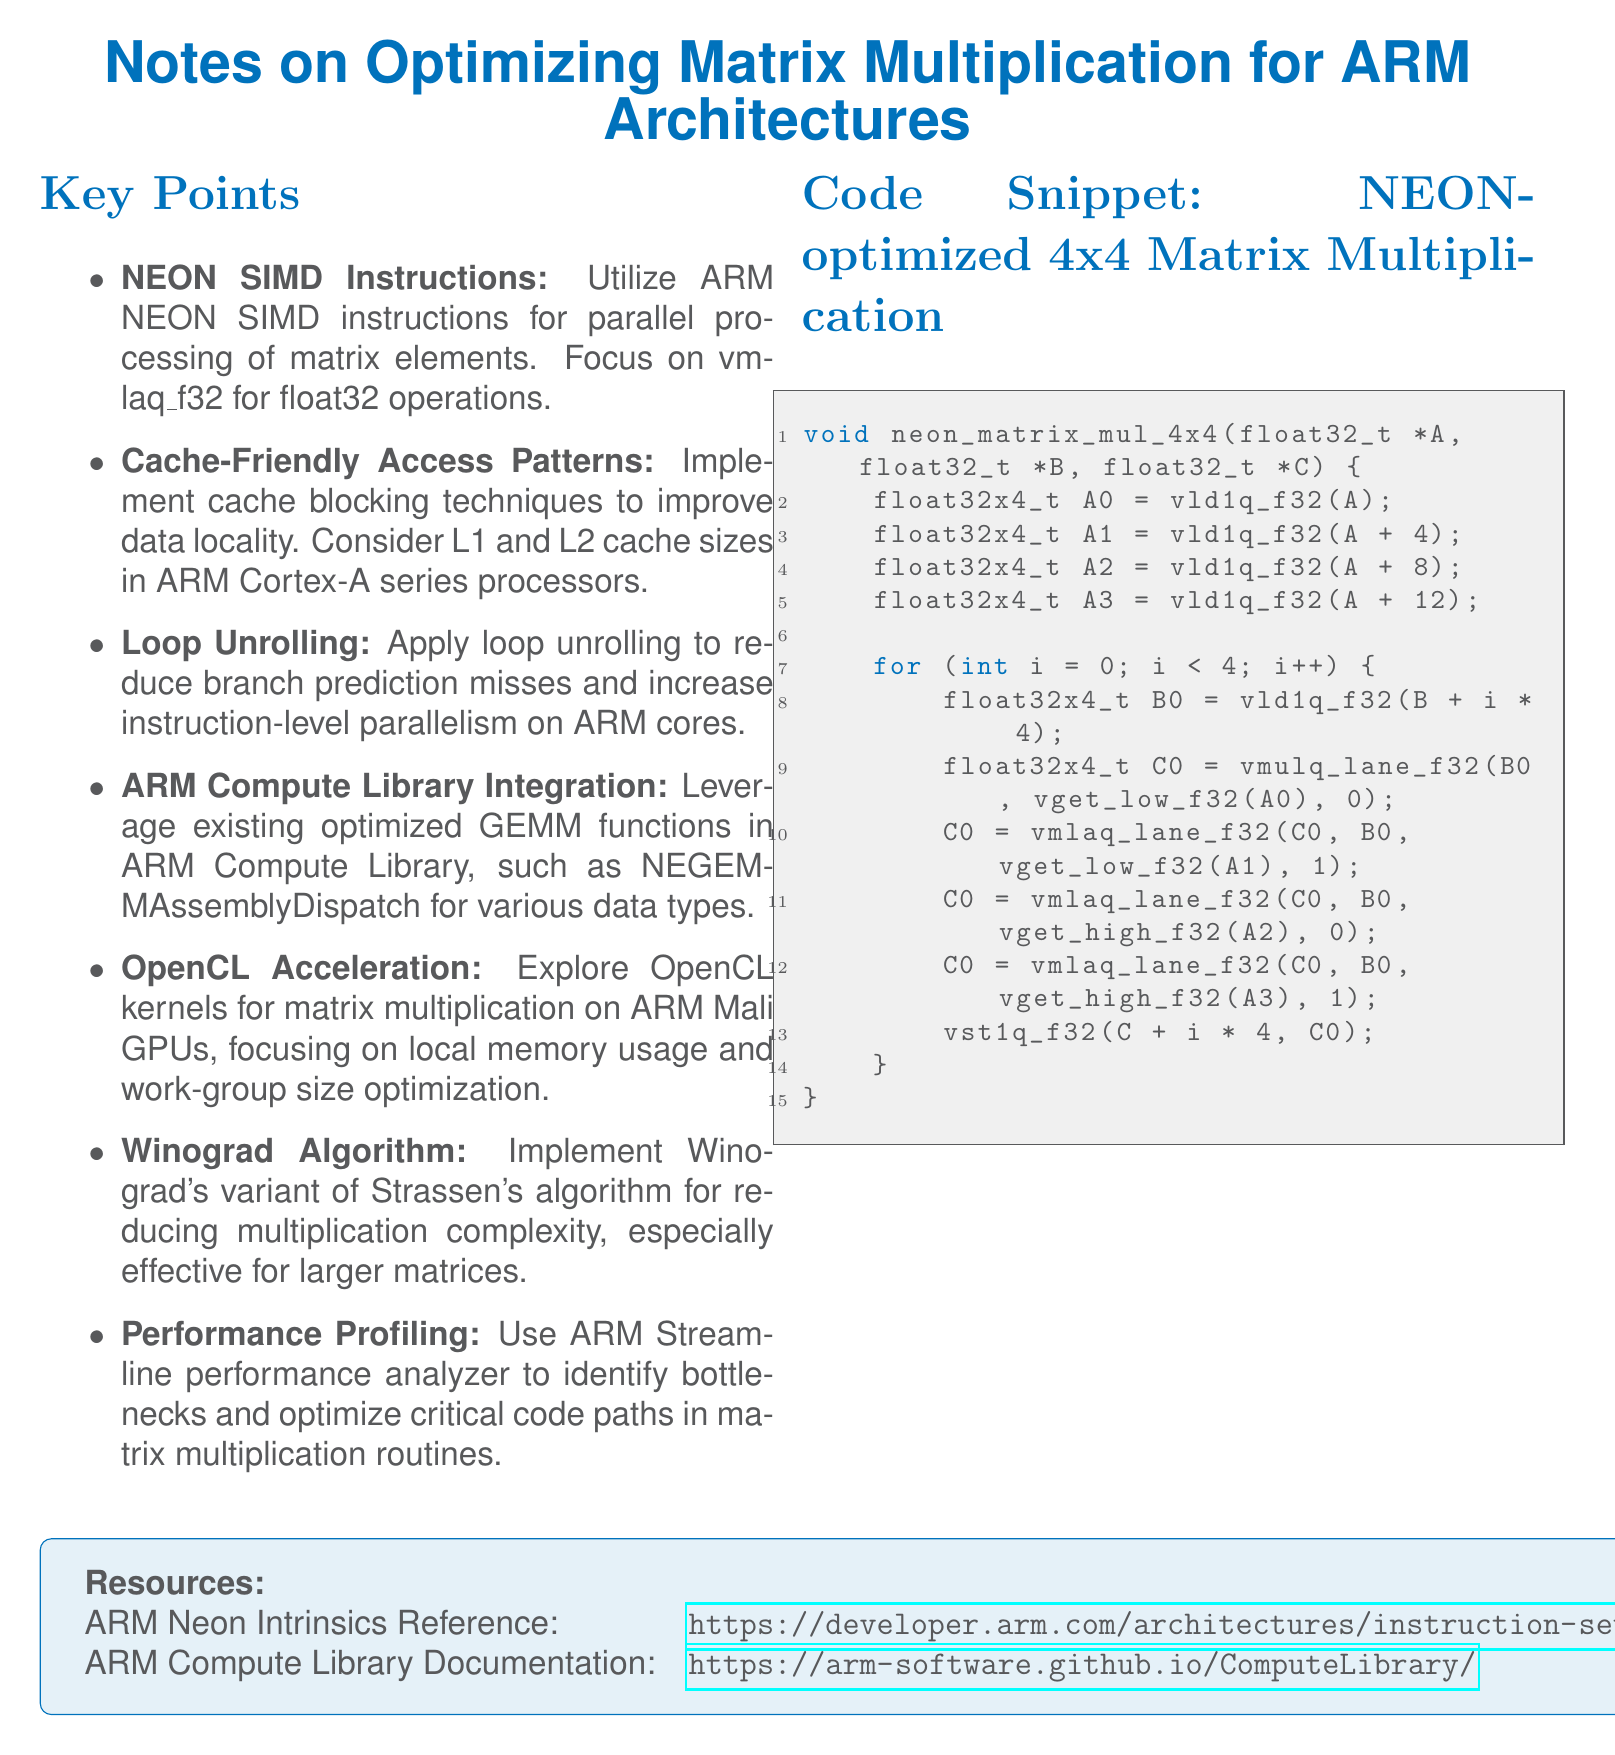What is the focus of NEON SIMD instructions? The NEON SIMD instructions focus on parallel processing of matrix elements, specifically vmlaq_f32 for float32 operations.
Answer: vmlaq_f32 for float32 operations What technique is suggested for improving data locality? The document suggests implementing cache blocking techniques to improve data locality.
Answer: Cache blocking techniques Which algorithm is mentioned for reducing multiplication complexity? The document mentions Winograd's variant of Strassen's algorithm for reducing multiplication complexity.
Answer: Winograd's variant of Strassen's algorithm What analysis tool is recommended for identifying bottlenecks? The recommended tool for identifying bottlenecks in matrix multiplication routines is the ARM Streamline performance analyzer.
Answer: ARM Streamline performance analyzer What is the size of the matrix being multiplied in the code snippet? The code snippet provided in the document focuses on a 4x4 matrix multiplication kernel.
Answer: 4x4 What type of functions are integrated from the ARM Compute Library? The document states that optimized GEMM functions are leveraged from the ARM Compute Library.
Answer: Optimized GEMM functions Which type of processors are referenced for cache sizes? The ARM Cortex-A series processors are referenced regarding cache sizes in the document.
Answer: ARM Cortex-A series processors How many key points are listed in the document? The document lists seven key points related to optimizing matrix multiplication for ARM architectures.
Answer: Seven What programming language is used in the code snippet? The programming language used in the code snippet is C++.
Answer: C++ 